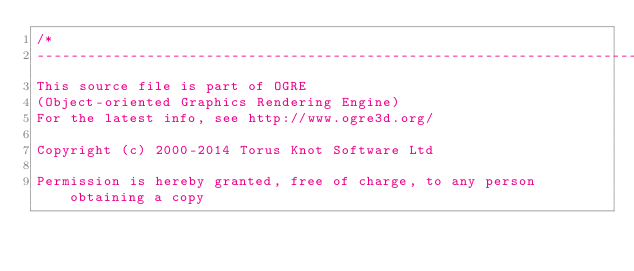<code> <loc_0><loc_0><loc_500><loc_500><_C_>/*
-----------------------------------------------------------------------------
This source file is part of OGRE
(Object-oriented Graphics Rendering Engine)
For the latest info, see http://www.ogre3d.org/

Copyright (c) 2000-2014 Torus Knot Software Ltd

Permission is hereby granted, free of charge, to any person obtaining a copy</code> 